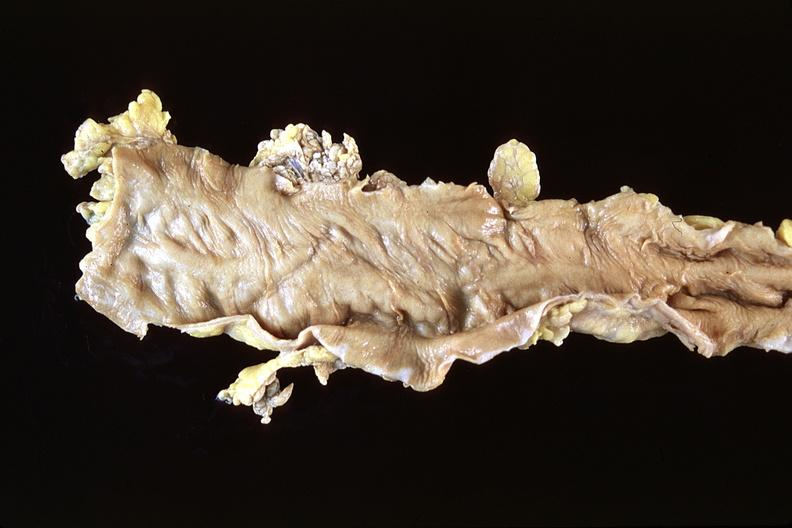what does this image show?
Answer the question using a single word or phrase. Normal colon 